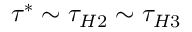<formula> <loc_0><loc_0><loc_500><loc_500>\tau ^ { * } \sim \tau _ { H 2 } \sim \tau _ { H 3 }</formula> 